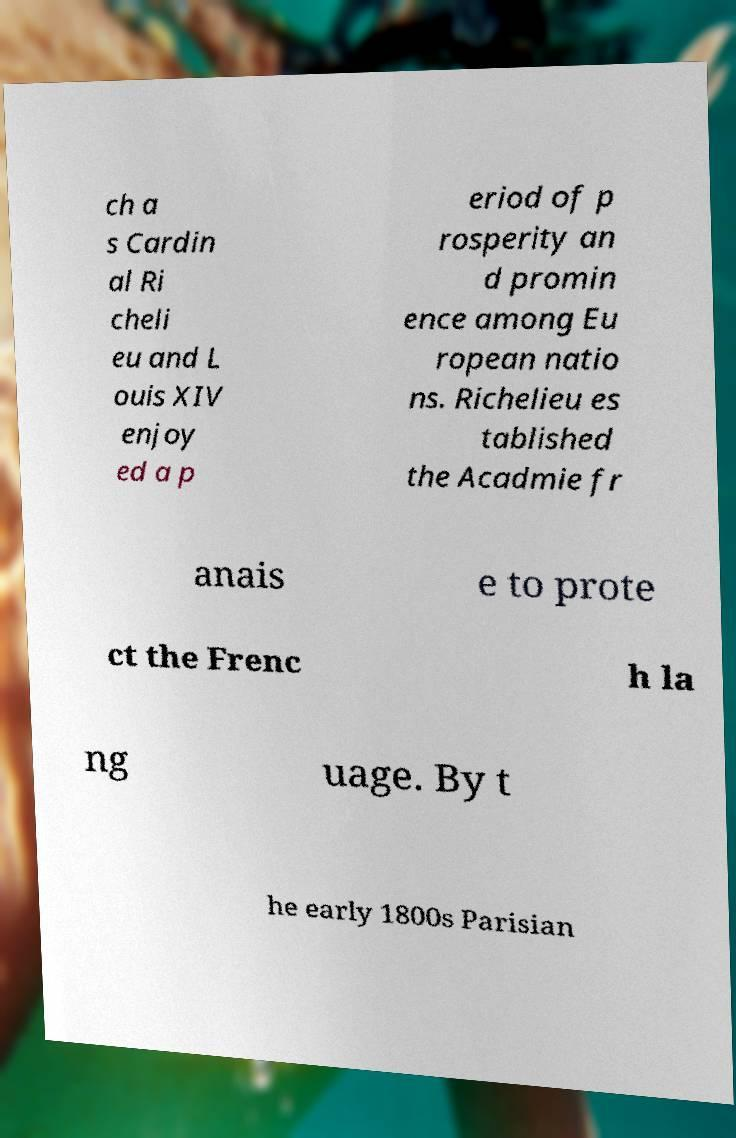What messages or text are displayed in this image? I need them in a readable, typed format. ch a s Cardin al Ri cheli eu and L ouis XIV enjoy ed a p eriod of p rosperity an d promin ence among Eu ropean natio ns. Richelieu es tablished the Acadmie fr anais e to prote ct the Frenc h la ng uage. By t he early 1800s Parisian 